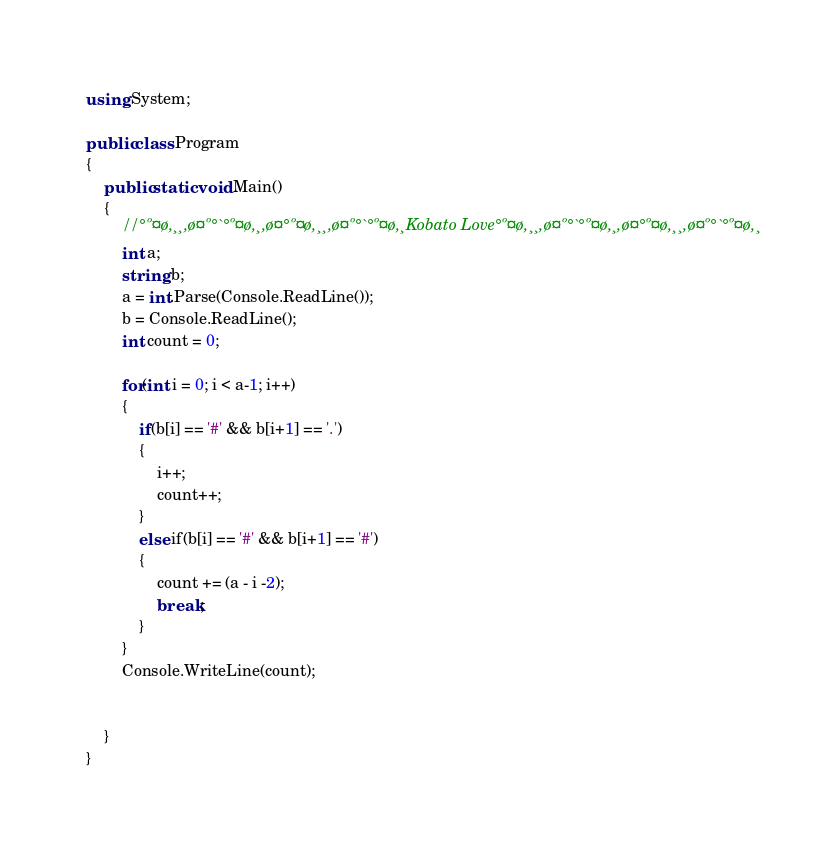Convert code to text. <code><loc_0><loc_0><loc_500><loc_500><_C#_>using System;
					
public class Program
{
	public static void Main()
	{
		//°º¤ø,¸¸,ø¤º°`°º¤ø,¸,ø¤°º¤ø,¸¸,ø¤º°`°º¤ø,¸Kobato Love°º¤ø,¸¸,ø¤º°`°º¤ø,¸,ø¤°º¤ø,¸¸,ø¤º°`°º¤ø,¸
		int a;
		string b;
		a = int.Parse(Console.ReadLine()); 
		b = Console.ReadLine(); 
		int count = 0;
		
		for(int i = 0; i < a-1; i++)
		{
			if(b[i] == '#' && b[i+1] == '.')
			{
				i++;
				count++;	
			}
			else if(b[i] == '#' && b[i+1] == '#')
			{
				count += (a - i -2);
				break;
			}
		}
		Console.WriteLine(count);
		
		
	}
}
</code> 